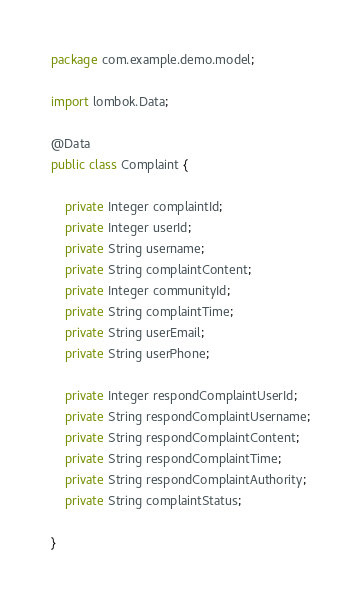Convert code to text. <code><loc_0><loc_0><loc_500><loc_500><_Java_>package com.example.demo.model;

import lombok.Data;

@Data
public class Complaint {

    private Integer complaintId;
    private Integer userId;
    private String username;
    private String complaintContent;
    private Integer communityId;
    private String complaintTime;
    private String userEmail;
    private String userPhone;

    private Integer respondComplaintUserId;
    private String respondComplaintUsername;
    private String respondComplaintContent;
    private String respondComplaintTime;
    private String respondComplaintAuthority;
    private String complaintStatus;

}
</code> 